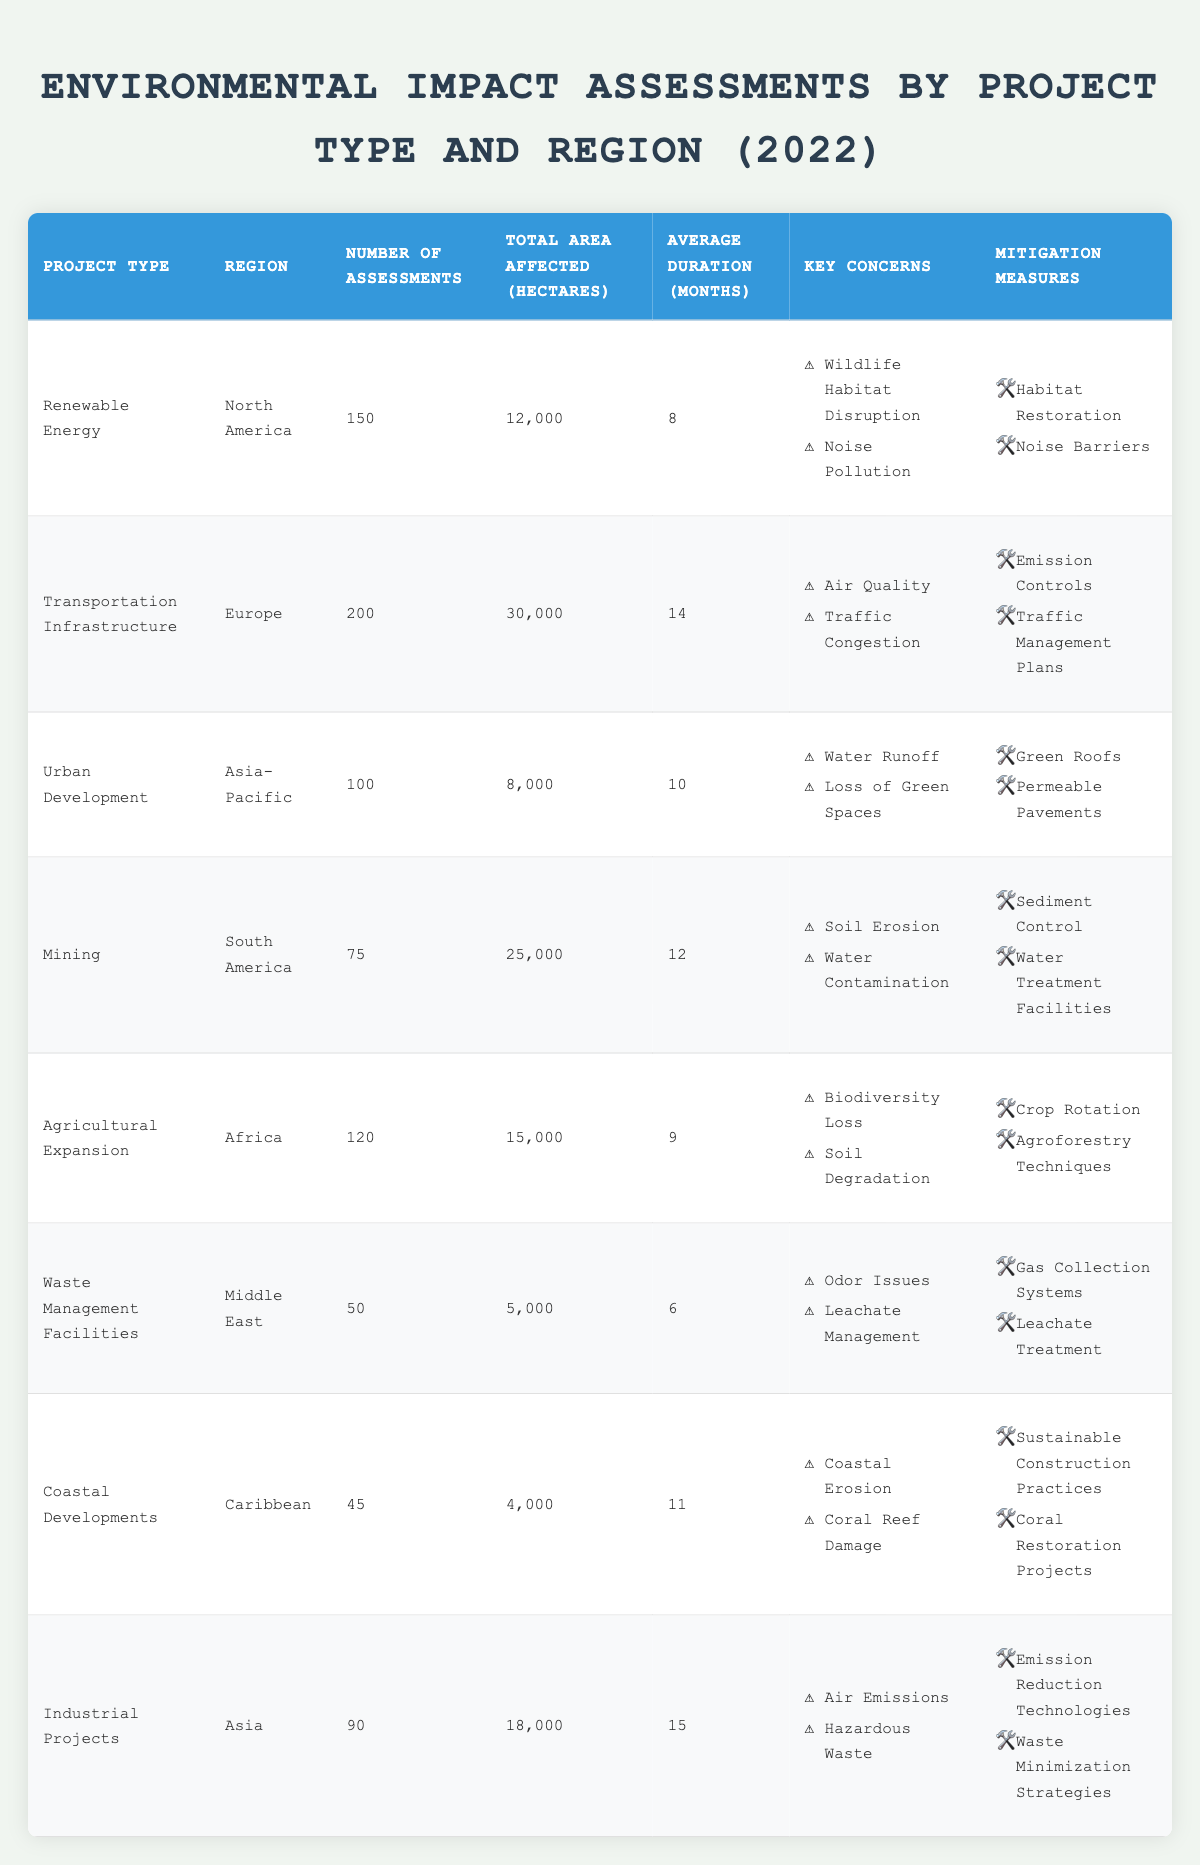What is the total area affected by Transportation Infrastructure projects in Europe? By looking at the Transportation Infrastructure row in the table, the total area affected in hectares is listed as 30,000.
Answer: 30,000 How many Environmental Impact Assessments were conducted for Renewable Energy projects? The row for Renewable Energy indicates that there were 150 assessments conducted.
Answer: 150 What are the key concerns associated with Urban Development in the Asia-Pacific region? The key concerns listed for Urban Development are Water Runoff and Loss of Green Spaces, as per the corresponding row in the table.
Answer: Water Runoff, Loss of Green Spaces What is the average duration of assessments for Mining projects? The average duration for Mining assessments is specified as 12 months in the corresponding row of the table.
Answer: 12 months Which project type has the highest number of assessments, and what is that number? By comparing all the numbers in the Number of Assessments column, Transportation Infrastructure with 200 assessments is the highest.
Answer: Transportation Infrastructure, 200 What is the difference in the total area affected between Industrial Projects and Mining? The total area affected by Industrial Projects is 18,000 hectares and for Mining it is 25,000 hectares. The difference is 25,000 - 18,000 = 7,000 hectares.
Answer: 7,000 hectares Which region has the lowest number of Environmental Impact Assessments, and how many? By reviewing the Number of Assessments column, Coastal Developments in the Caribbean has the lowest number at 45 assessments.
Answer: Caribbean, 45 If you combine the number of assessments for Renewable Energy and Agricultural Expansion, how many assessments would that total? The total number of assessments for Renewable Energy is 150, and for Agricultural Expansion, it is 120. Thus, the total is 150 + 120 = 270 assessments.
Answer: 270 Is it true that Waste Management Facilities have the highest average duration of assessments? The data shows that Waste Management Facilities have an average duration of 6 months, while Industrial Projects have 15 months, which is higher. Thus, it is false.
Answer: No How many more hectares are affected by Transportation Infrastructure than by Urban Development? Transportation Infrastructure affects 30,000 hectares and Urban Development affects 8,000 hectares. Thus, the difference is 30,000 - 8,000 = 22,000 hectares.
Answer: 22,000 hectares 